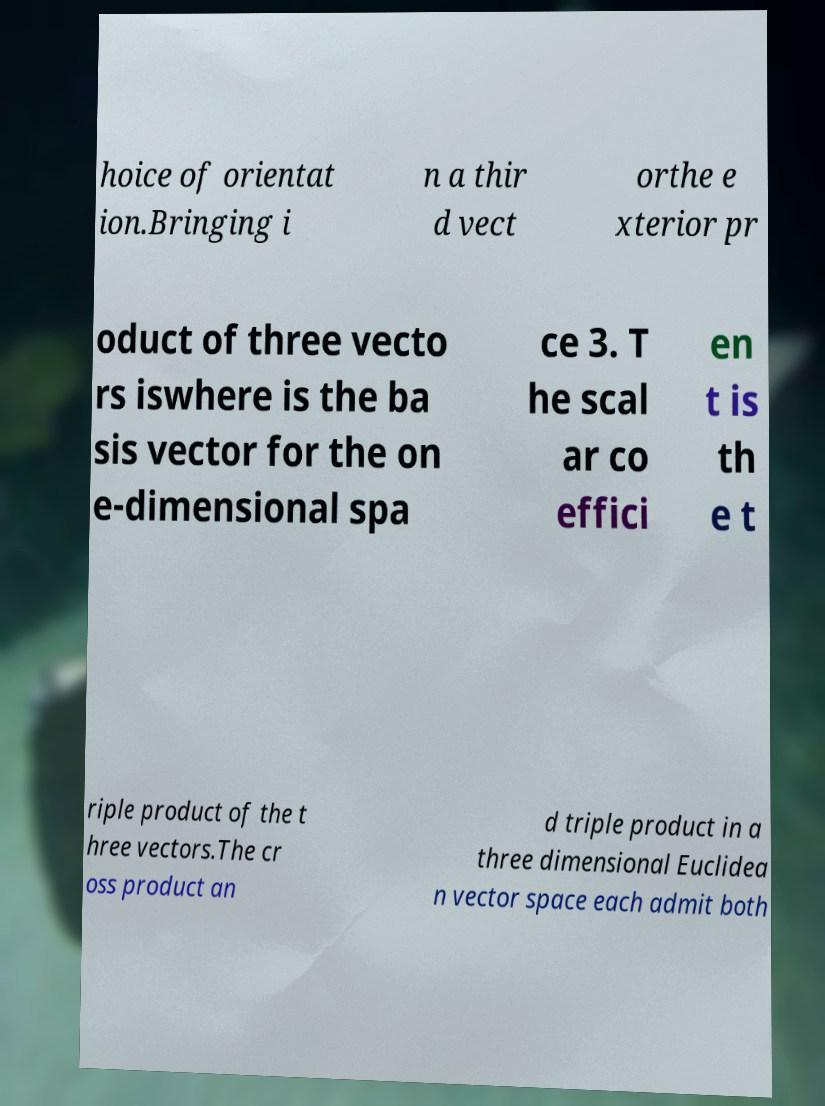Please read and relay the text visible in this image. What does it say? hoice of orientat ion.Bringing i n a thir d vect orthe e xterior pr oduct of three vecto rs iswhere is the ba sis vector for the on e-dimensional spa ce 3. T he scal ar co effici en t is th e t riple product of the t hree vectors.The cr oss product an d triple product in a three dimensional Euclidea n vector space each admit both 